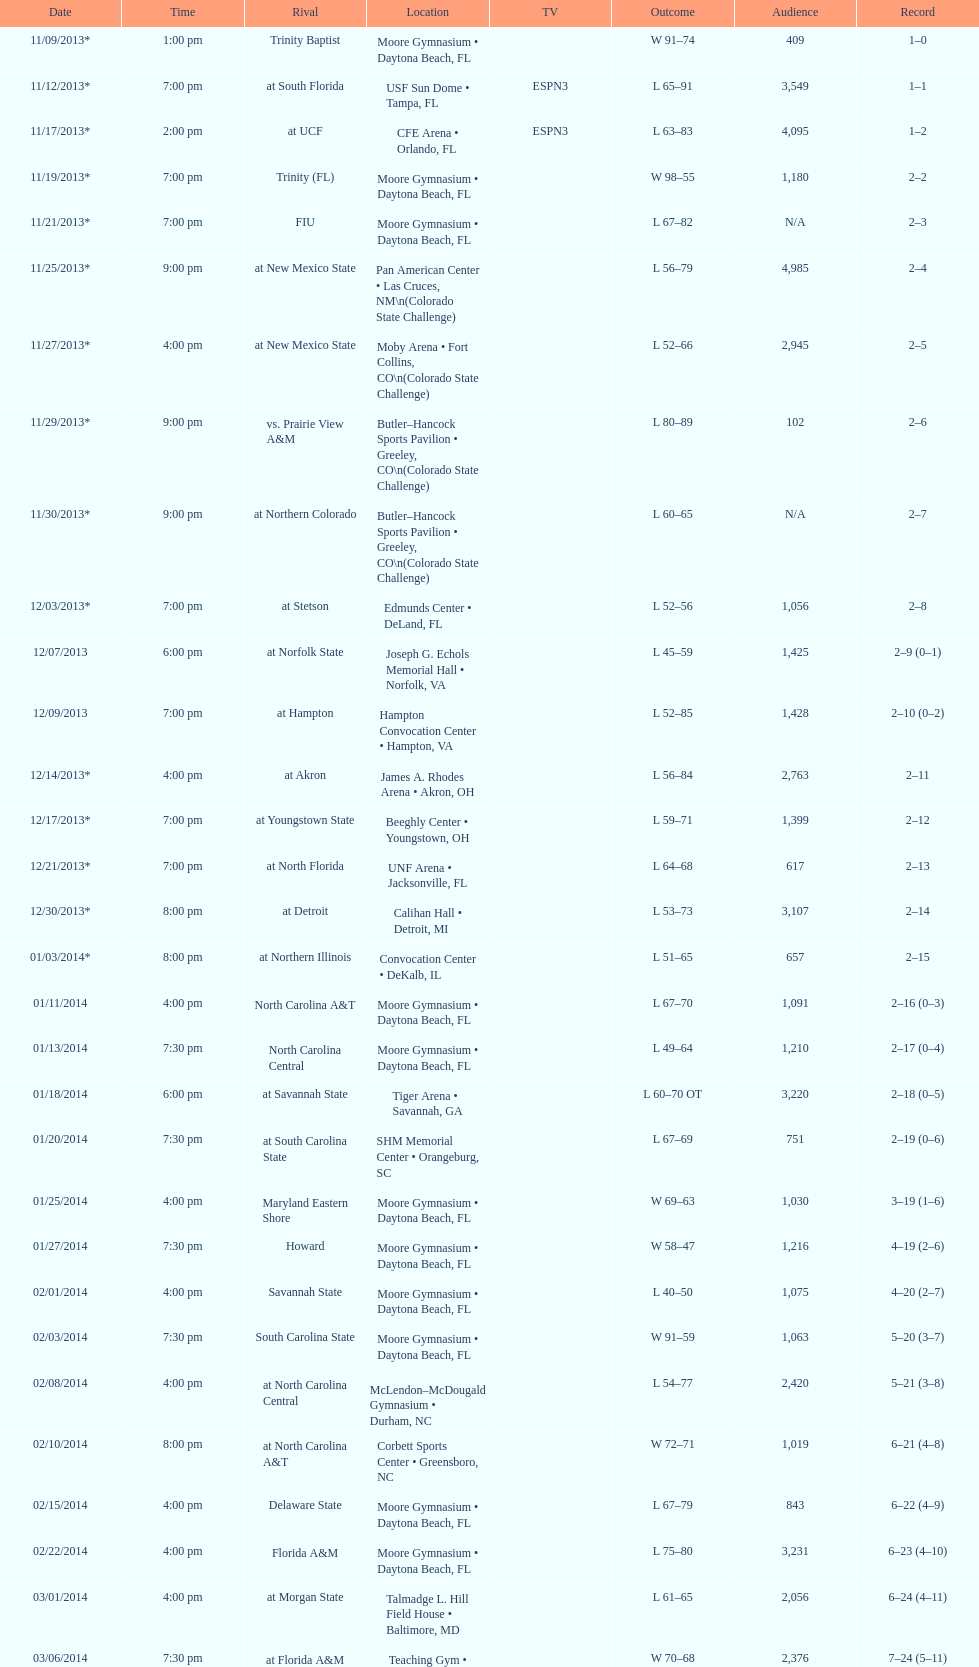Which game was won by a bigger margin, against trinity (fl) or against trinity baptist? Trinity (FL). 